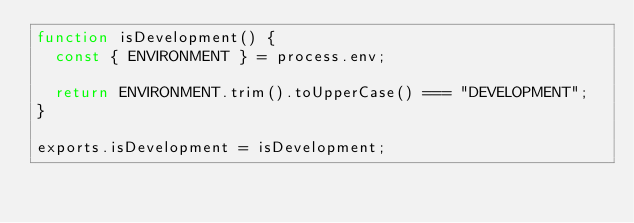Convert code to text. <code><loc_0><loc_0><loc_500><loc_500><_JavaScript_>function isDevelopment() {
  const { ENVIRONMENT } = process.env;

  return ENVIRONMENT.trim().toUpperCase() === "DEVELOPMENT";
}

exports.isDevelopment = isDevelopment;
</code> 